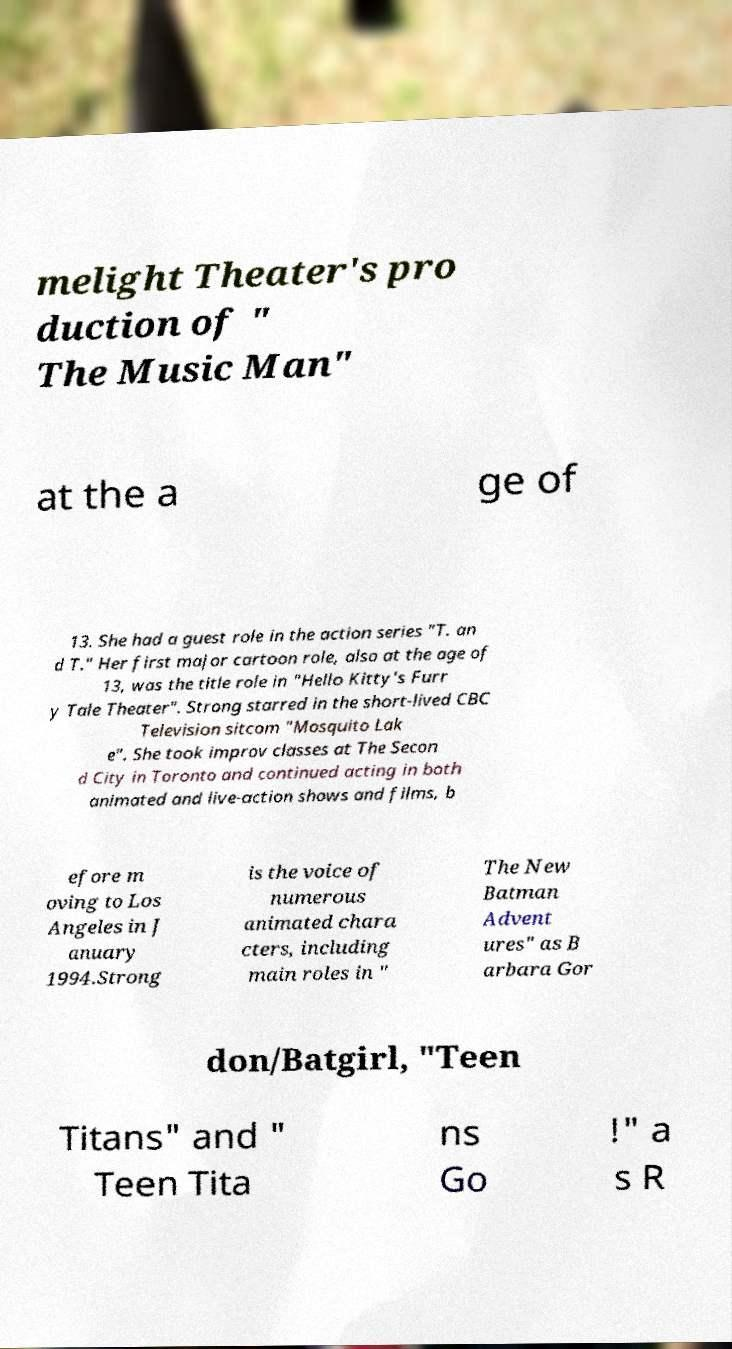Please identify and transcribe the text found in this image. melight Theater's pro duction of " The Music Man" at the a ge of 13. She had a guest role in the action series "T. an d T." Her first major cartoon role, also at the age of 13, was the title role in "Hello Kitty's Furr y Tale Theater". Strong starred in the short-lived CBC Television sitcom "Mosquito Lak e". She took improv classes at The Secon d City in Toronto and continued acting in both animated and live-action shows and films, b efore m oving to Los Angeles in J anuary 1994.Strong is the voice of numerous animated chara cters, including main roles in " The New Batman Advent ures" as B arbara Gor don/Batgirl, "Teen Titans" and " Teen Tita ns Go !" a s R 